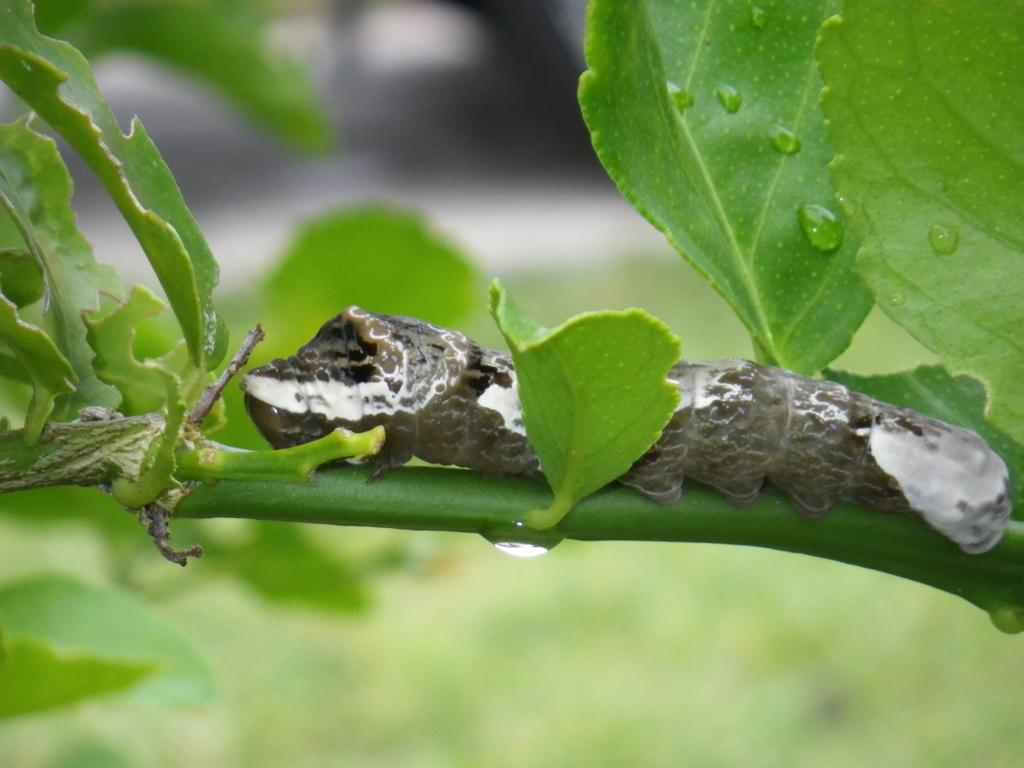What is present in the image? There is a plant in the image. Can you describe the plant? There is an insect on the plant. What can be observed about the background of the image? The background of the image is blurred. How many bikes are hanging from the plant in the image? There are no bikes present in the image; it features a plant with an insect on it. What type of heart can be seen beating in the image? There is no heart present in the image; it only features a plant and an insect. 